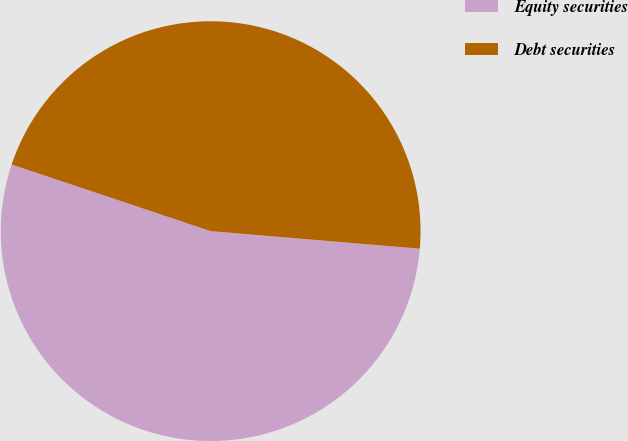Convert chart. <chart><loc_0><loc_0><loc_500><loc_500><pie_chart><fcel>Equity securities<fcel>Debt securities<nl><fcel>53.81%<fcel>46.19%<nl></chart> 